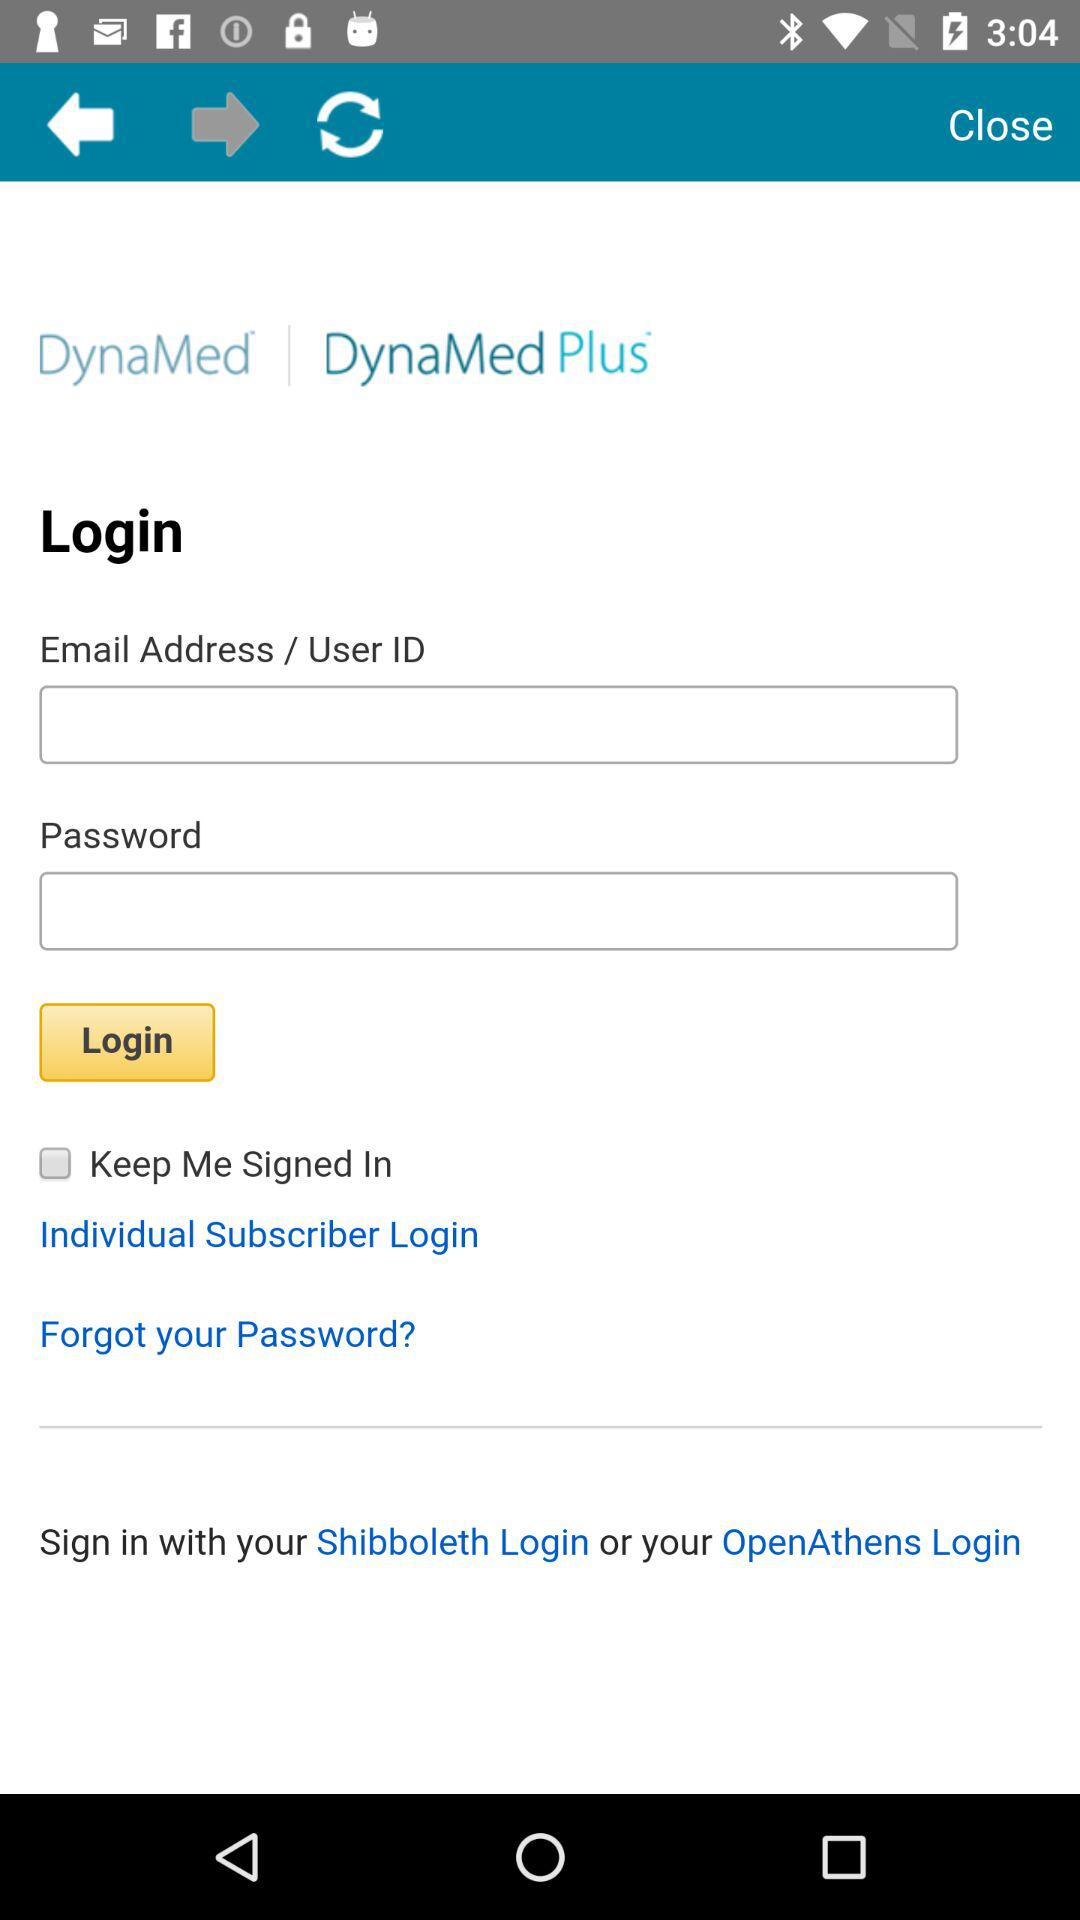What is the status of "Keep Me Signed In"? The status of "Keep Me Signed In" is "off". 